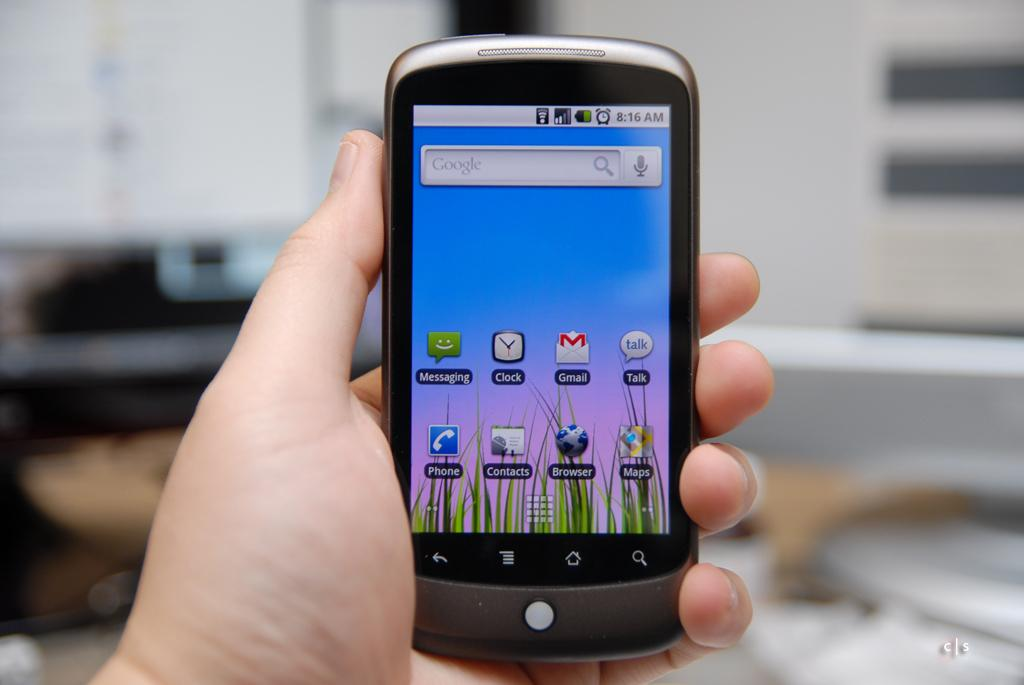<image>
Provide a brief description of the given image. Left hand holding a large cellphone with Yahoo Gmail and other apps on front of screen. 